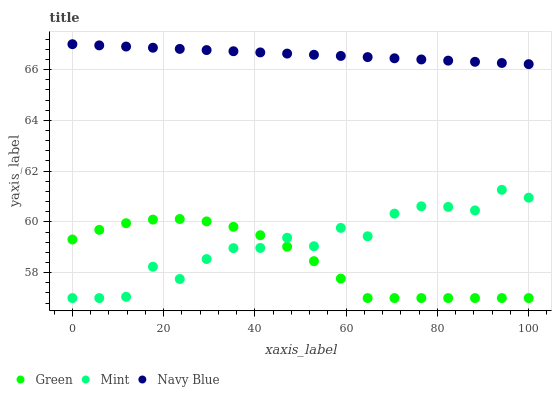Does Green have the minimum area under the curve?
Answer yes or no. Yes. Does Navy Blue have the maximum area under the curve?
Answer yes or no. Yes. Does Navy Blue have the minimum area under the curve?
Answer yes or no. No. Does Green have the maximum area under the curve?
Answer yes or no. No. Is Navy Blue the smoothest?
Answer yes or no. Yes. Is Mint the roughest?
Answer yes or no. Yes. Is Green the smoothest?
Answer yes or no. No. Is Green the roughest?
Answer yes or no. No. Does Mint have the lowest value?
Answer yes or no. Yes. Does Navy Blue have the lowest value?
Answer yes or no. No. Does Navy Blue have the highest value?
Answer yes or no. Yes. Does Green have the highest value?
Answer yes or no. No. Is Green less than Navy Blue?
Answer yes or no. Yes. Is Navy Blue greater than Green?
Answer yes or no. Yes. Does Mint intersect Green?
Answer yes or no. Yes. Is Mint less than Green?
Answer yes or no. No. Is Mint greater than Green?
Answer yes or no. No. Does Green intersect Navy Blue?
Answer yes or no. No. 